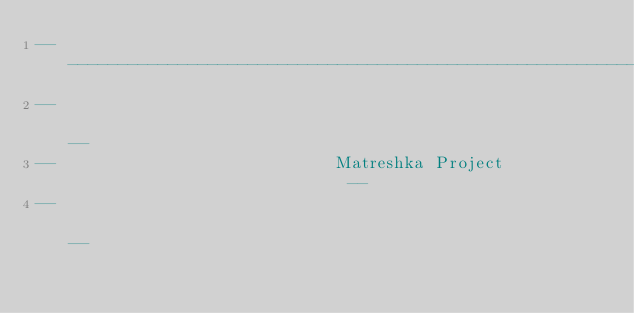Convert code to text. <code><loc_0><loc_0><loc_500><loc_500><_Ada_>------------------------------------------------------------------------------
--                                                                          --
--                            Matreshka Project                             --
--                                                                          --</code> 